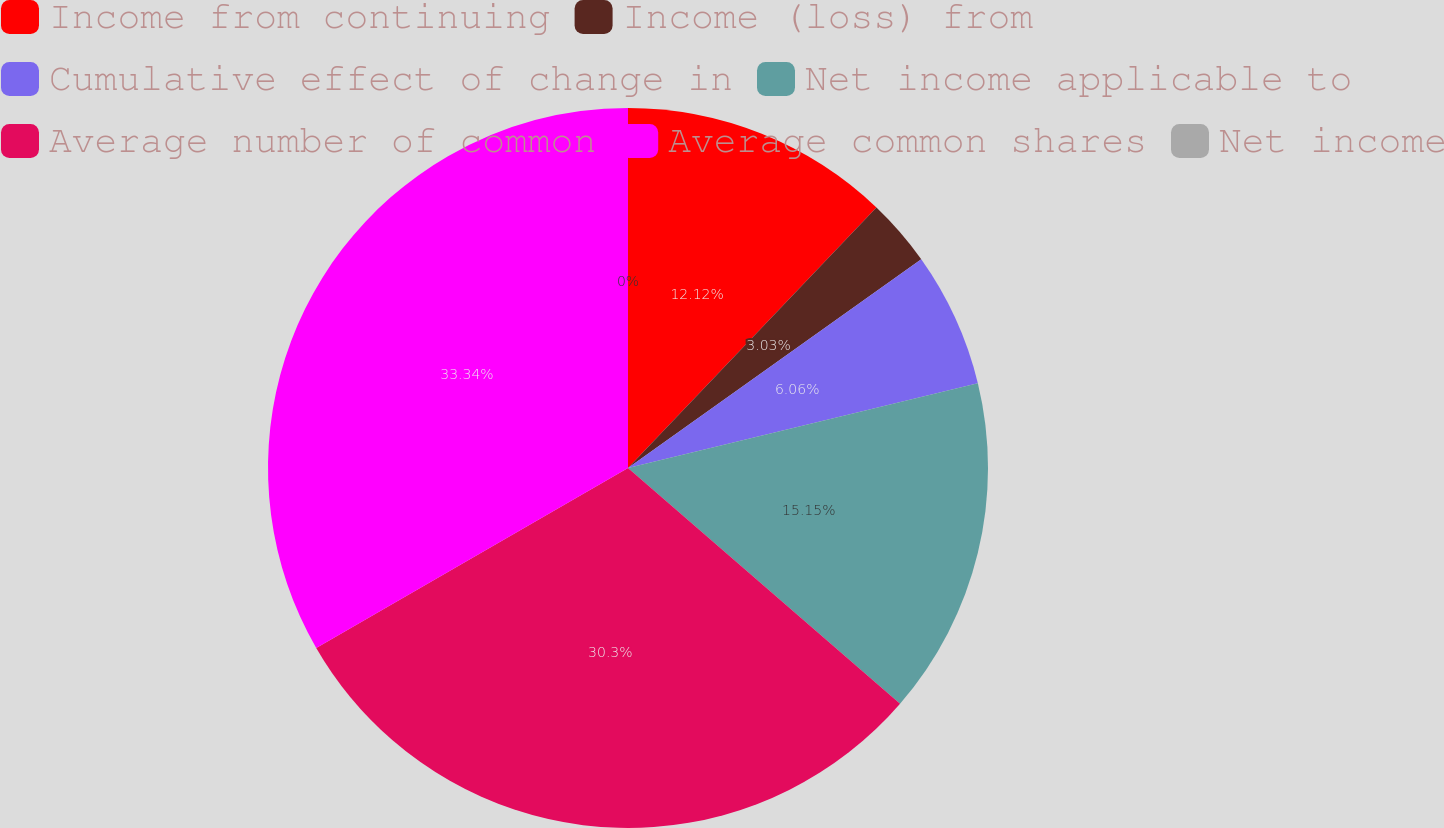Convert chart to OTSL. <chart><loc_0><loc_0><loc_500><loc_500><pie_chart><fcel>Income from continuing<fcel>Income (loss) from<fcel>Cumulative effect of change in<fcel>Net income applicable to<fcel>Average number of common<fcel>Average common shares<fcel>Net income<nl><fcel>12.12%<fcel>3.03%<fcel>6.06%<fcel>15.15%<fcel>30.3%<fcel>33.33%<fcel>0.0%<nl></chart> 